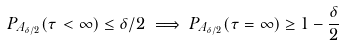Convert formula to latex. <formula><loc_0><loc_0><loc_500><loc_500>P _ { A _ { \delta / 2 } } ( \tau < \infty ) \leq \delta / 2 \implies P _ { A _ { \delta / 2 } } ( \tau = \infty ) \geq 1 - \frac { \delta } { 2 }</formula> 